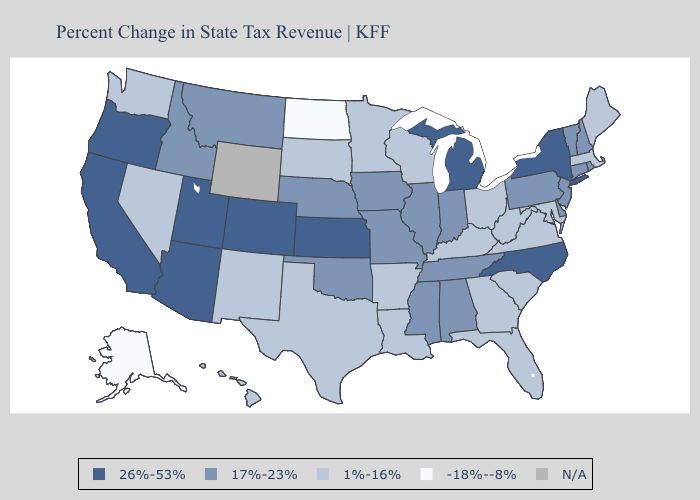What is the value of Nevada?
Quick response, please. 1%-16%. What is the highest value in states that border Montana?
Concise answer only. 17%-23%. Does Minnesota have the highest value in the USA?
Be succinct. No. What is the highest value in states that border Kansas?
Answer briefly. 26%-53%. Does Vermont have the highest value in the Northeast?
Keep it brief. No. How many symbols are there in the legend?
Answer briefly. 5. Among the states that border South Dakota , which have the highest value?
Be succinct. Iowa, Montana, Nebraska. What is the value of Oklahoma?
Answer briefly. 17%-23%. Among the states that border North Carolina , which have the highest value?
Concise answer only. Tennessee. Name the states that have a value in the range 17%-23%?
Concise answer only. Alabama, Connecticut, Delaware, Idaho, Illinois, Indiana, Iowa, Mississippi, Missouri, Montana, Nebraska, New Hampshire, New Jersey, Oklahoma, Pennsylvania, Rhode Island, Tennessee, Vermont. Name the states that have a value in the range 1%-16%?
Concise answer only. Arkansas, Florida, Georgia, Hawaii, Kentucky, Louisiana, Maine, Maryland, Massachusetts, Minnesota, Nevada, New Mexico, Ohio, South Carolina, South Dakota, Texas, Virginia, Washington, West Virginia, Wisconsin. What is the value of Connecticut?
Answer briefly. 17%-23%. What is the value of Arizona?
Keep it brief. 26%-53%. Name the states that have a value in the range 1%-16%?
Give a very brief answer. Arkansas, Florida, Georgia, Hawaii, Kentucky, Louisiana, Maine, Maryland, Massachusetts, Minnesota, Nevada, New Mexico, Ohio, South Carolina, South Dakota, Texas, Virginia, Washington, West Virginia, Wisconsin. 